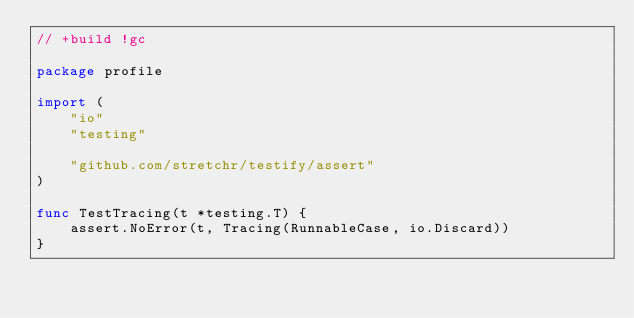<code> <loc_0><loc_0><loc_500><loc_500><_Go_>// +build !gc

package profile

import (
	"io"
	"testing"

	"github.com/stretchr/testify/assert"
)

func TestTracing(t *testing.T) {
	assert.NoError(t, Tracing(RunnableCase, io.Discard))
}
</code> 